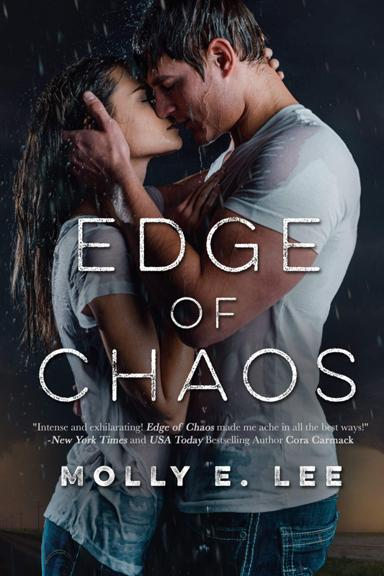How might the scene depicted on the cover symbolize the book's theme or story? The intense and raw depiction of a couple embracing amid a storm on the cover likely symbolizes the turmoil and passion within the storyline. This visual metaphor could suggest themes of overcoming challenges and the power of love amidst chaos. 